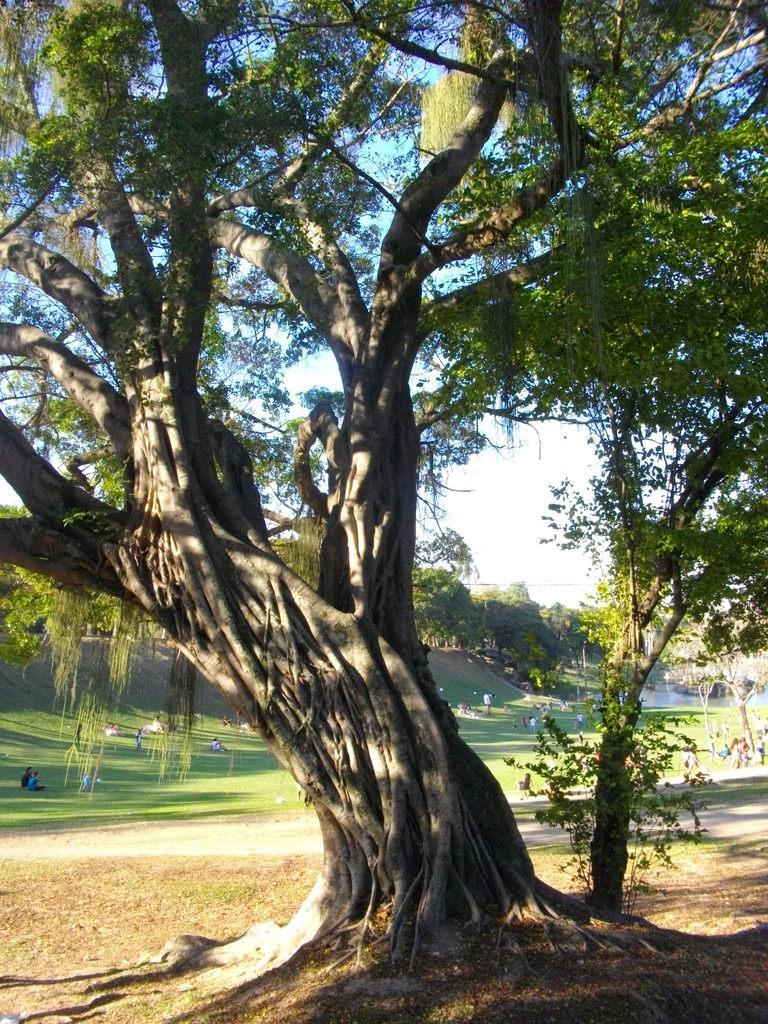What type of vegetation can be seen in the image? There are trees in the image. What is on the ground in the image? There is grass on the ground in the image. Are there any people in the image? Yes, there are persons in the image. What can be seen in the sky in the image? There are clouds visible in the sky in the image. What type of oven can be seen in the image? There is no oven present in the image. How does the pollution affect the trees in the image? There is no mention of pollution in the image, and therefore its effect on the trees cannot be determined. 